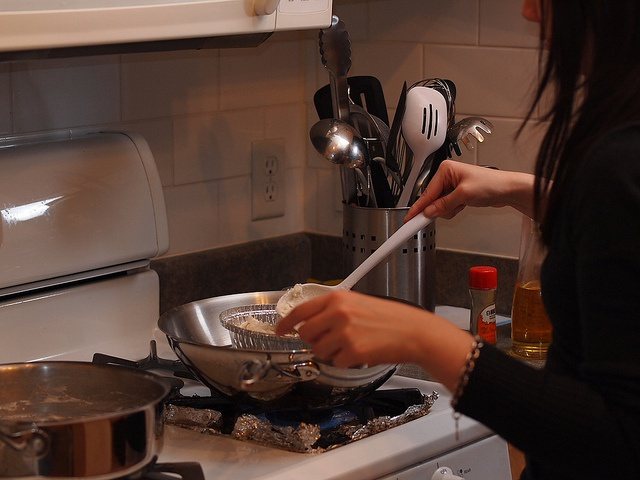Describe the objects in this image and their specific colors. I can see people in tan, black, maroon, brown, and red tones, oven in tan, black, gray, and darkgray tones, bottle in tan, maroon, and brown tones, spoon in tan, brown, darkgray, and gray tones, and bowl in tan, maroon, gray, and brown tones in this image. 